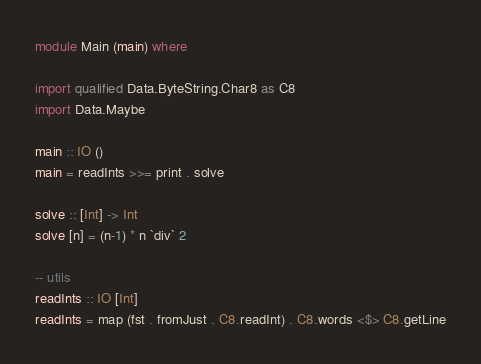<code> <loc_0><loc_0><loc_500><loc_500><_Haskell_>module Main (main) where

import qualified Data.ByteString.Char8 as C8
import Data.Maybe

main :: IO ()
main = readInts >>= print . solve

solve :: [Int] -> Int
solve [n] = (n-1) * n `div` 2

-- utils
readInts :: IO [Int]
readInts = map (fst . fromJust . C8.readInt) . C8.words <$> C8.getLine</code> 